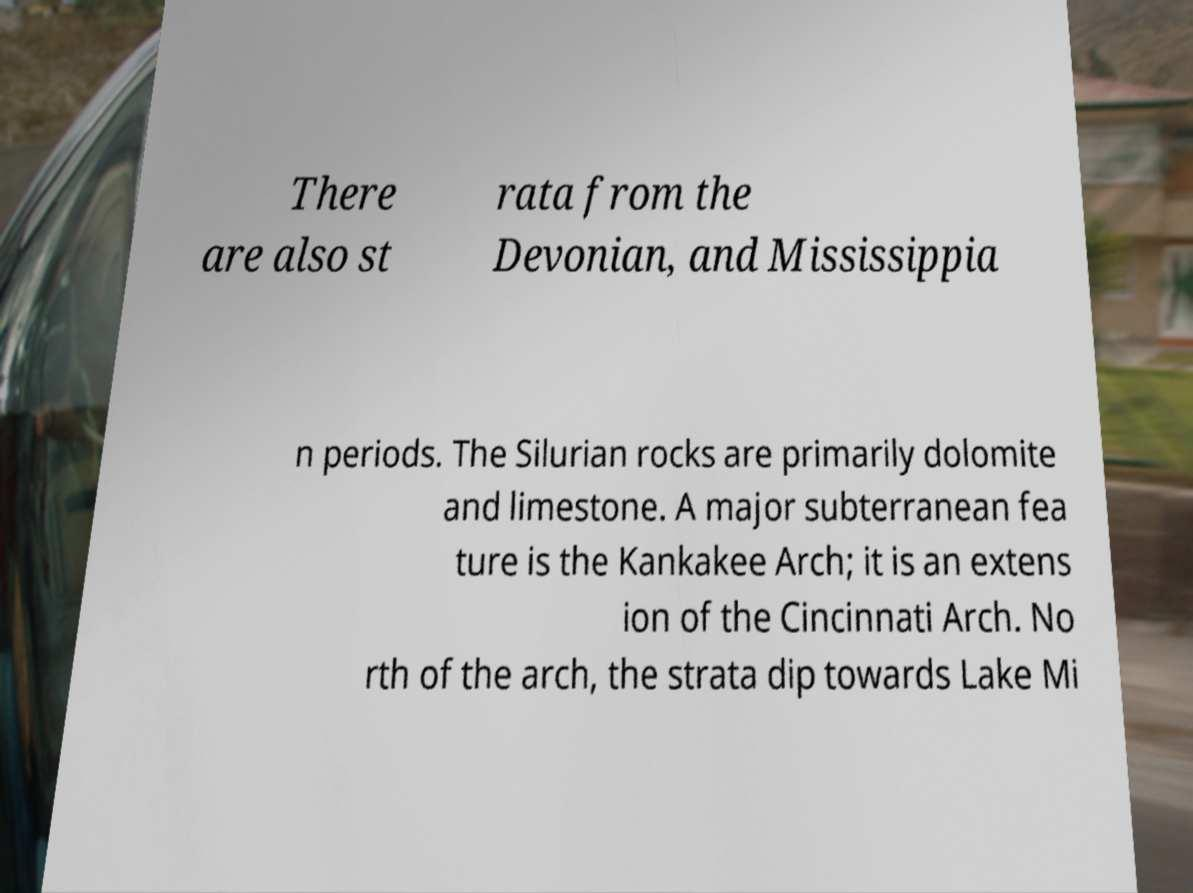Can you accurately transcribe the text from the provided image for me? There are also st rata from the Devonian, and Mississippia n periods. The Silurian rocks are primarily dolomite and limestone. A major subterranean fea ture is the Kankakee Arch; it is an extens ion of the Cincinnati Arch. No rth of the arch, the strata dip towards Lake Mi 